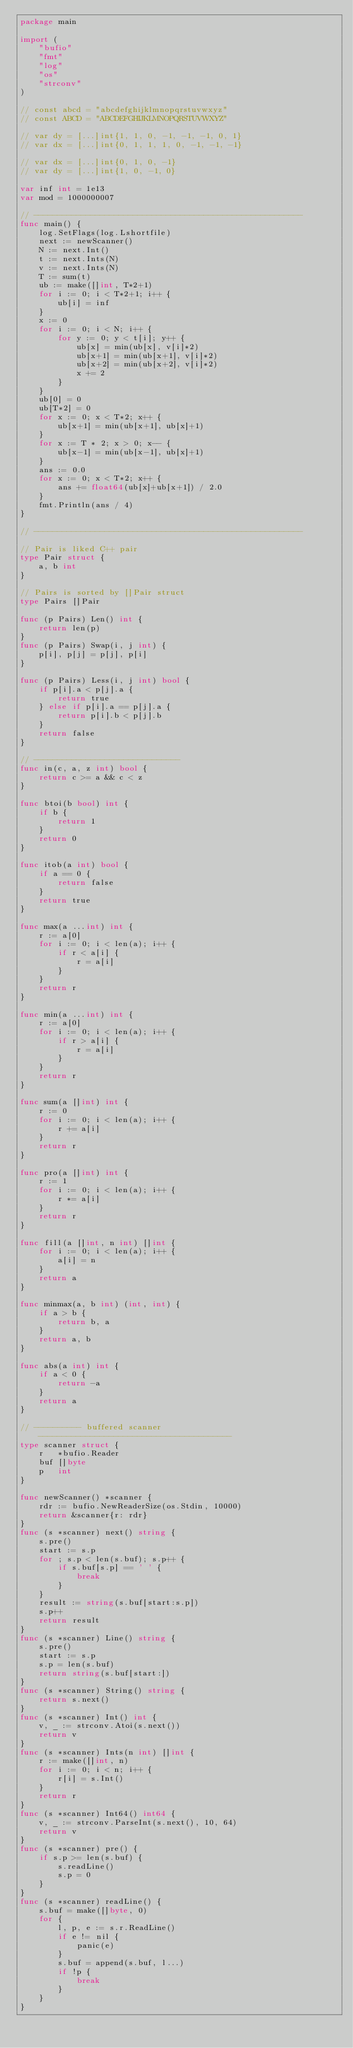Convert code to text. <code><loc_0><loc_0><loc_500><loc_500><_Go_>package main

import (
	"bufio"
	"fmt"
	"log"
	"os"
	"strconv"
)

// const abcd = "abcdefghijklmnopqrstuvwxyz"
// const ABCD = "ABCDEFGHIJKLMNOPQRSTUVWXYZ"

// var dy = [...]int{1, 1, 0, -1, -1, -1, 0, 1}
// var dx = [...]int{0, 1, 1, 1, 0, -1, -1, -1}

// var dx = [...]int{0, 1, 0, -1}
// var dy = [...]int{1, 0, -1, 0}

var inf int = 1e13
var mod = 1000000007

// ---------------------------------------------------------
func main() {
	log.SetFlags(log.Lshortfile)
	next := newScanner()
	N := next.Int()
	t := next.Ints(N)
	v := next.Ints(N)
	T := sum(t)
	ub := make([]int, T*2+1)
	for i := 0; i < T*2+1; i++ {
		ub[i] = inf
	}
	x := 0
	for i := 0; i < N; i++ {
		for y := 0; y < t[i]; y++ {
			ub[x] = min(ub[x], v[i]*2)
			ub[x+1] = min(ub[x+1], v[i]*2)
			ub[x+2] = min(ub[x+2], v[i]*2)
			x += 2
		}
	}
	ub[0] = 0
	ub[T*2] = 0
	for x := 0; x < T*2; x++ {
		ub[x+1] = min(ub[x+1], ub[x]+1)
	}
	for x := T * 2; x > 0; x-- {
		ub[x-1] = min(ub[x-1], ub[x]+1)
	}
	ans := 0.0
	for x := 0; x < T*2; x++ {
		ans += float64(ub[x]+ub[x+1]) / 2.0
	}
	fmt.Println(ans / 4)
}

// ---------------------------------------------------------

// Pair is liked C++ pair
type Pair struct {
	a, b int
}

// Pairs is sorted by []Pair struct
type Pairs []Pair

func (p Pairs) Len() int {
	return len(p)
}
func (p Pairs) Swap(i, j int) {
	p[i], p[j] = p[j], p[i]
}

func (p Pairs) Less(i, j int) bool {
	if p[i].a < p[j].a {
		return true
	} else if p[i].a == p[j].a {
		return p[i].b < p[j].b
	}
	return false
}

// -------------------------------
func in(c, a, z int) bool {
	return c >= a && c < z
}

func btoi(b bool) int {
	if b {
		return 1
	}
	return 0
}

func itob(a int) bool {
	if a == 0 {
		return false
	}
	return true
}

func max(a ...int) int {
	r := a[0]
	for i := 0; i < len(a); i++ {
		if r < a[i] {
			r = a[i]
		}
	}
	return r
}

func min(a ...int) int {
	r := a[0]
	for i := 0; i < len(a); i++ {
		if r > a[i] {
			r = a[i]
		}
	}
	return r
}

func sum(a []int) int {
	r := 0
	for i := 0; i < len(a); i++ {
		r += a[i]
	}
	return r
}

func pro(a []int) int {
	r := 1
	for i := 0; i < len(a); i++ {
		r *= a[i]
	}
	return r
}

func fill(a []int, n int) []int {
	for i := 0; i < len(a); i++ {
		a[i] = n
	}
	return a
}

func minmax(a, b int) (int, int) {
	if a > b {
		return b, a
	}
	return a, b
}

func abs(a int) int {
	if a < 0 {
		return -a
	}
	return a
}

// ---------- buffered scanner -----------------------------------------
type scanner struct {
	r   *bufio.Reader
	buf []byte
	p   int
}

func newScanner() *scanner {
	rdr := bufio.NewReaderSize(os.Stdin, 10000)
	return &scanner{r: rdr}
}
func (s *scanner) next() string {
	s.pre()
	start := s.p
	for ; s.p < len(s.buf); s.p++ {
		if s.buf[s.p] == ' ' {
			break
		}
	}
	result := string(s.buf[start:s.p])
	s.p++
	return result
}
func (s *scanner) Line() string {
	s.pre()
	start := s.p
	s.p = len(s.buf)
	return string(s.buf[start:])
}
func (s *scanner) String() string {
	return s.next()
}
func (s *scanner) Int() int {
	v, _ := strconv.Atoi(s.next())
	return v
}
func (s *scanner) Ints(n int) []int {
	r := make([]int, n)
	for i := 0; i < n; i++ {
		r[i] = s.Int()
	}
	return r
}
func (s *scanner) Int64() int64 {
	v, _ := strconv.ParseInt(s.next(), 10, 64)
	return v
}
func (s *scanner) pre() {
	if s.p >= len(s.buf) {
		s.readLine()
		s.p = 0
	}
}
func (s *scanner) readLine() {
	s.buf = make([]byte, 0)
	for {
		l, p, e := s.r.ReadLine()
		if e != nil {
			panic(e)
		}
		s.buf = append(s.buf, l...)
		if !p {
			break
		}
	}
}
</code> 